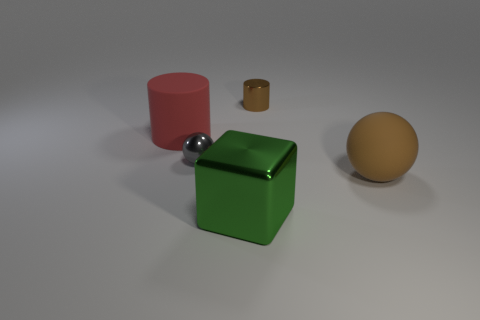Is the shape of the brown metal thing the same as the green object?
Make the answer very short. No. What number of brown objects are to the right of the object behind the large matte cylinder?
Provide a succinct answer. 1. There is a large object that is behind the big brown ball; is it the same shape as the metallic thing in front of the large brown sphere?
Provide a succinct answer. No. There is a metal thing that is in front of the metallic cylinder and behind the large cube; how big is it?
Ensure brevity in your answer.  Small. There is another object that is the same shape as the red rubber thing; what color is it?
Your answer should be very brief. Brown. The matte thing on the left side of the matte object on the right side of the red object is what color?
Provide a succinct answer. Red. There is a red matte thing; what shape is it?
Offer a terse response. Cylinder. There is a object that is both behind the gray ball and in front of the small metallic cylinder; what is its shape?
Offer a terse response. Cylinder. The cylinder that is the same material as the green block is what color?
Provide a short and direct response. Brown. What is the shape of the big thing that is in front of the ball that is in front of the ball that is to the left of the brown cylinder?
Keep it short and to the point. Cube. 